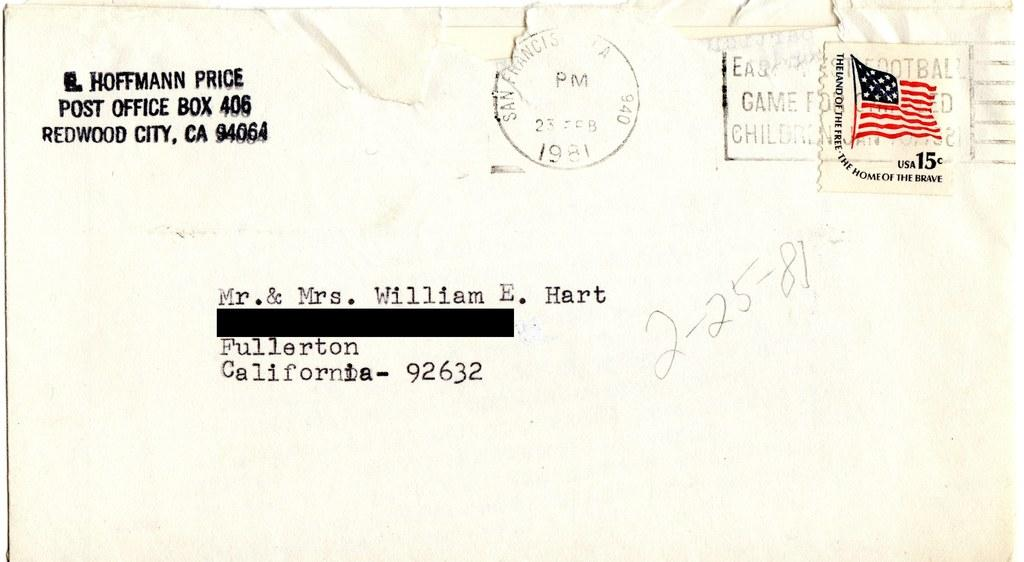<image>
Describe the image concisely. A letter comes from an address in Redwood City, California. 